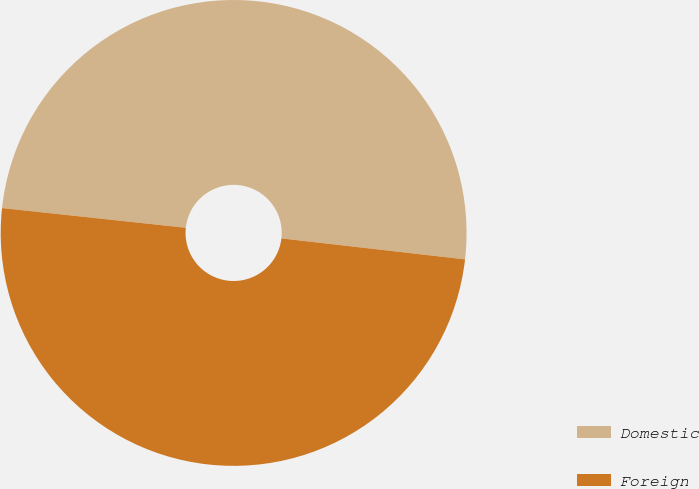<chart> <loc_0><loc_0><loc_500><loc_500><pie_chart><fcel>Domestic<fcel>Foreign<nl><fcel>50.11%<fcel>49.89%<nl></chart> 